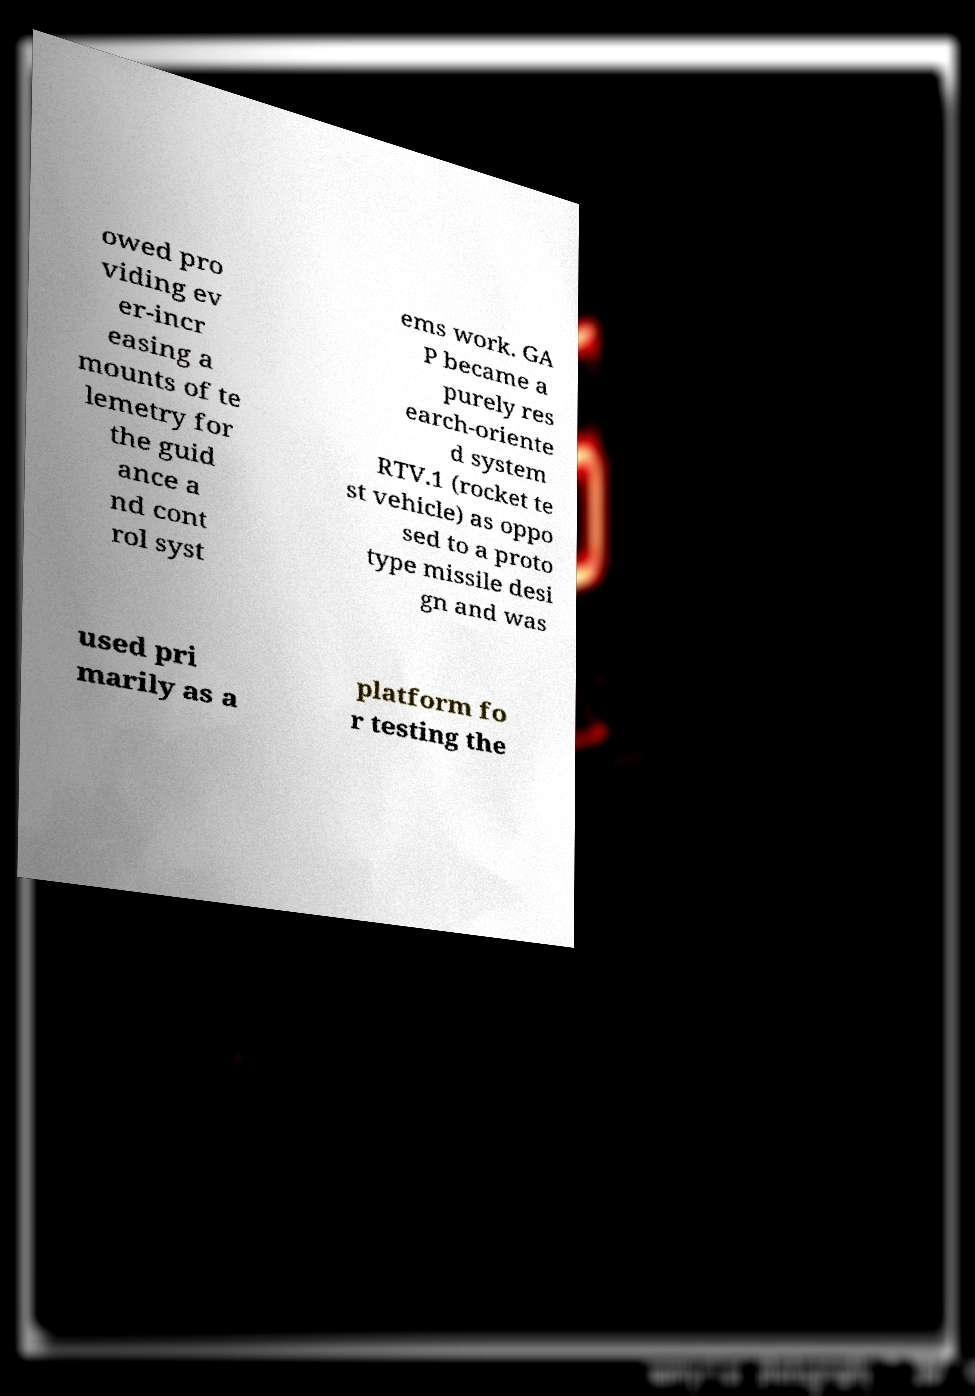There's text embedded in this image that I need extracted. Can you transcribe it verbatim? owed pro viding ev er-incr easing a mounts of te lemetry for the guid ance a nd cont rol syst ems work. GA P became a purely res earch-oriente d system RTV.1 (rocket te st vehicle) as oppo sed to a proto type missile desi gn and was used pri marily as a platform fo r testing the 